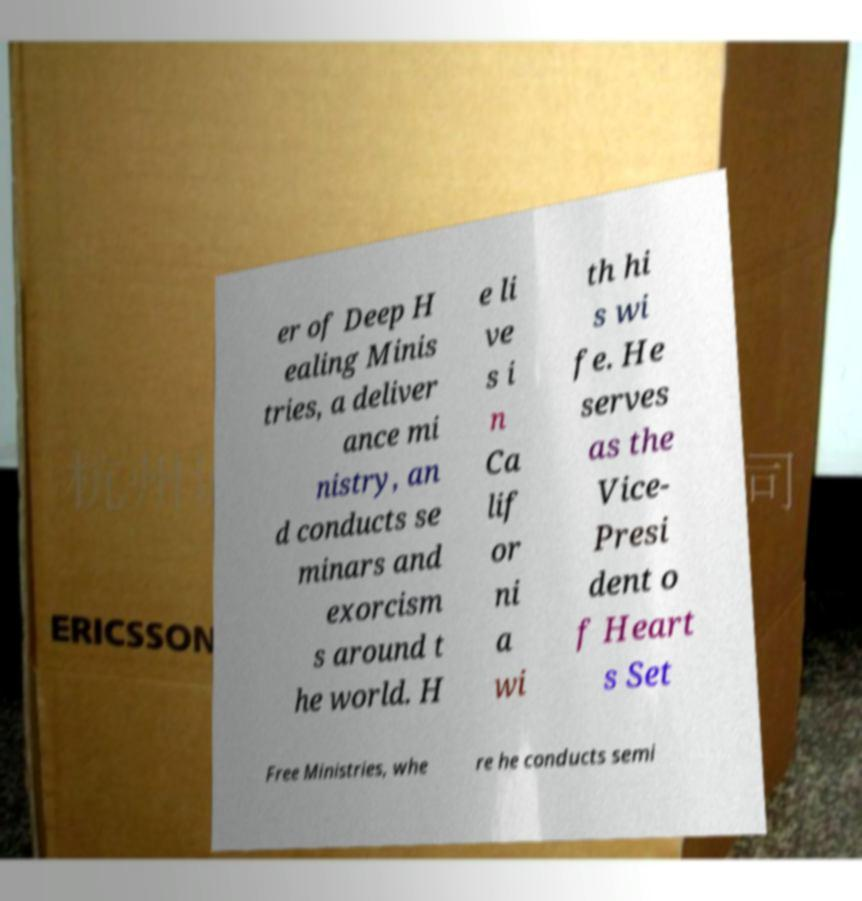There's text embedded in this image that I need extracted. Can you transcribe it verbatim? er of Deep H ealing Minis tries, a deliver ance mi nistry, an d conducts se minars and exorcism s around t he world. H e li ve s i n Ca lif or ni a wi th hi s wi fe. He serves as the Vice- Presi dent o f Heart s Set Free Ministries, whe re he conducts semi 